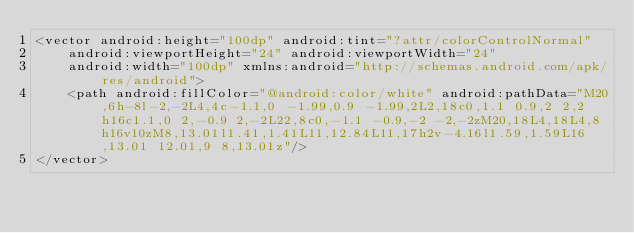Convert code to text. <code><loc_0><loc_0><loc_500><loc_500><_XML_><vector android:height="100dp" android:tint="?attr/colorControlNormal"
    android:viewportHeight="24" android:viewportWidth="24"
    android:width="100dp" xmlns:android="http://schemas.android.com/apk/res/android">
    <path android:fillColor="@android:color/white" android:pathData="M20,6h-8l-2,-2L4,4c-1.1,0 -1.99,0.9 -1.99,2L2,18c0,1.1 0.9,2 2,2h16c1.1,0 2,-0.9 2,-2L22,8c0,-1.1 -0.9,-2 -2,-2zM20,18L4,18L4,8h16v10zM8,13.01l1.41,1.41L11,12.84L11,17h2v-4.16l1.59,1.59L16,13.01 12.01,9 8,13.01z"/>
</vector>
</code> 